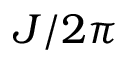<formula> <loc_0><loc_0><loc_500><loc_500>J / 2 \pi</formula> 